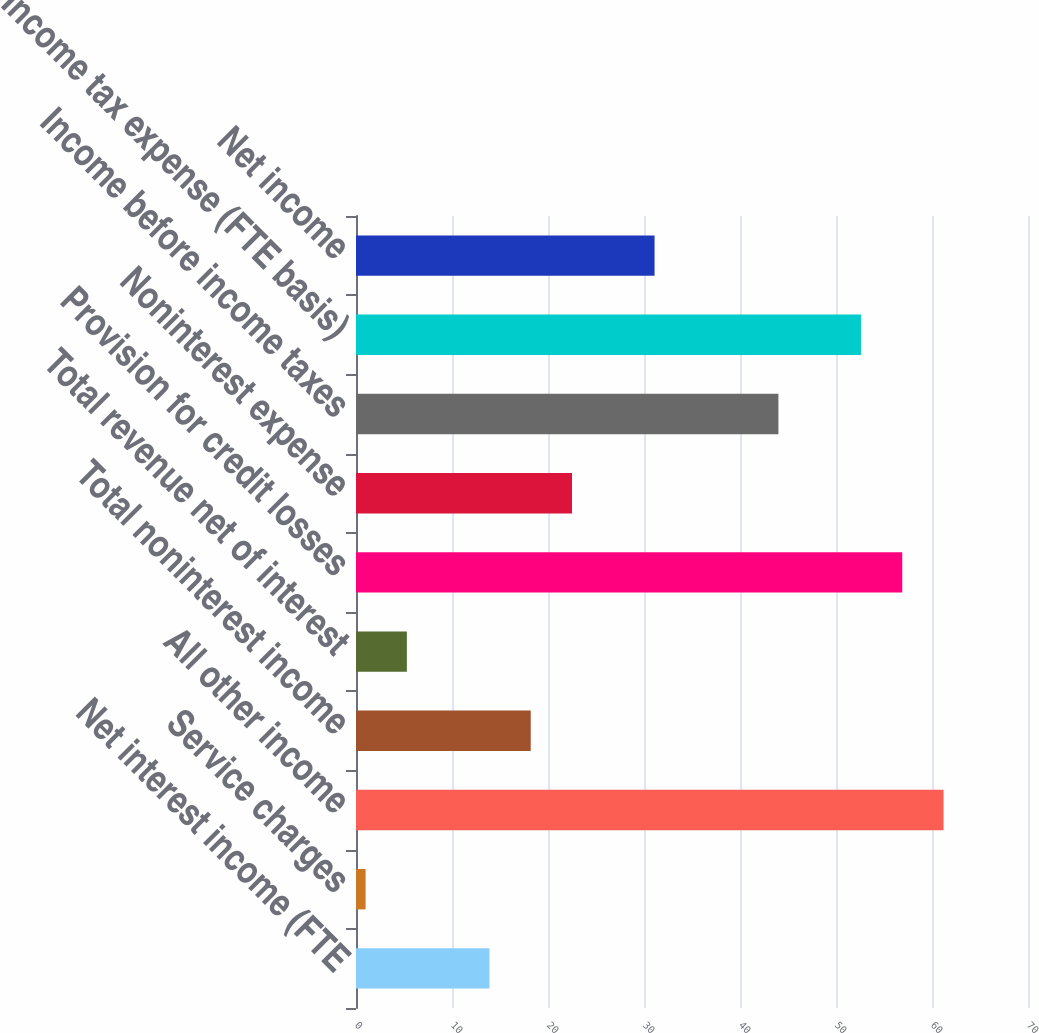Convert chart to OTSL. <chart><loc_0><loc_0><loc_500><loc_500><bar_chart><fcel>Net interest income (FTE<fcel>Service charges<fcel>All other income<fcel>Total noninterest income<fcel>Total revenue net of interest<fcel>Provision for credit losses<fcel>Noninterest expense<fcel>Income before income taxes<fcel>Income tax expense (FTE basis)<fcel>Net income<nl><fcel>13.9<fcel>1<fcel>61.2<fcel>18.2<fcel>5.3<fcel>56.9<fcel>22.5<fcel>44<fcel>52.6<fcel>31.1<nl></chart> 